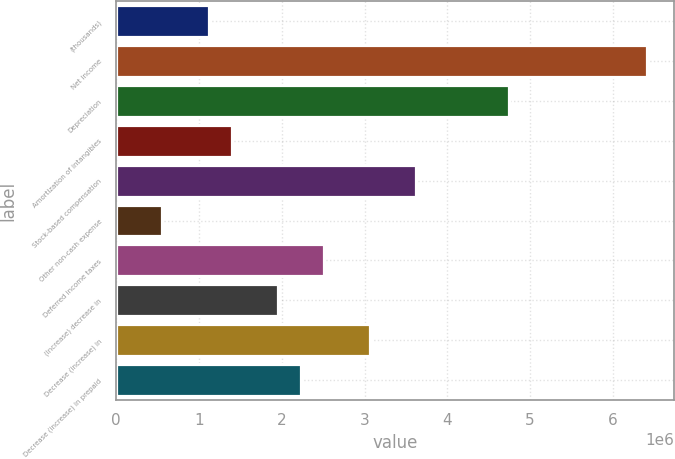Convert chart to OTSL. <chart><loc_0><loc_0><loc_500><loc_500><bar_chart><fcel>(thousands)<fcel>Net income<fcel>Depreciation<fcel>Amortization of intangibles<fcel>Stock-based compensation<fcel>Other non-cash expense<fcel>Deferred income taxes<fcel>(Increase) decrease in<fcel>Decrease (increase) in<fcel>Decrease (increase) in prepaid<nl><fcel>1.11561e+06<fcel>6.41379e+06<fcel>4.74068e+06<fcel>1.39446e+06<fcel>3.62527e+06<fcel>557903<fcel>2.50987e+06<fcel>1.95216e+06<fcel>3.06757e+06<fcel>2.23101e+06<nl></chart> 